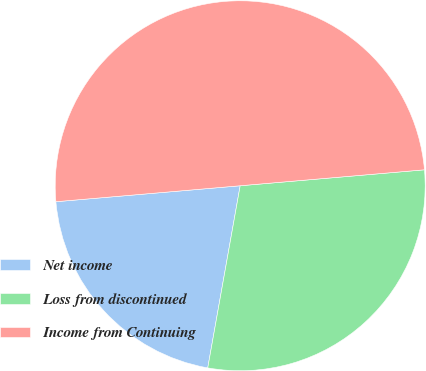Convert chart. <chart><loc_0><loc_0><loc_500><loc_500><pie_chart><fcel>Net income<fcel>Loss from discontinued<fcel>Income from Continuing<nl><fcel>20.82%<fcel>29.18%<fcel>50.0%<nl></chart> 